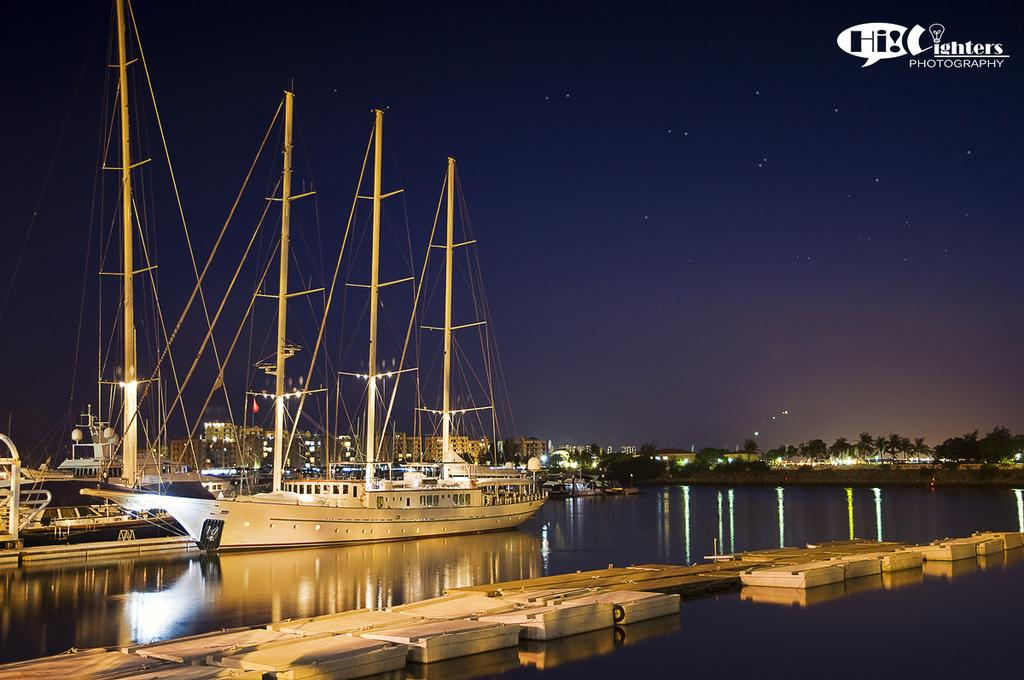What is in the water in the image? There are boats in the water in the image. What can be seen in the background of the image? There are buildings, lights, trees, and the sky visible in the background. What is the purpose of the watermark in the image? The watermark is at the top right side of the image, but its purpose is not clear from the provided facts. What type of meat is being delivered by the boats in the image? There is no meat or delivery of any kind depicted in the image; it features boats in the water and various background elements. What color is the pencil used to draw the trees in the background? There is no pencil or drawing present in the image; it is a photograph of a real-life scene. 